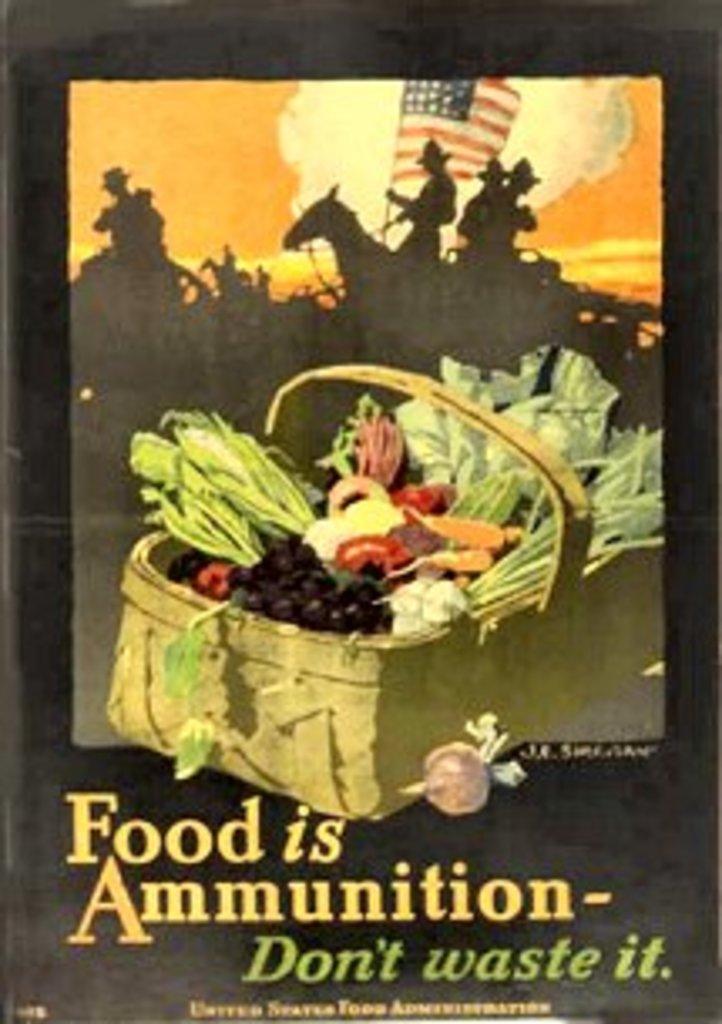What do you not waste?
Keep it short and to the point. Food. What is the first word of the title?
Offer a terse response. Food. 